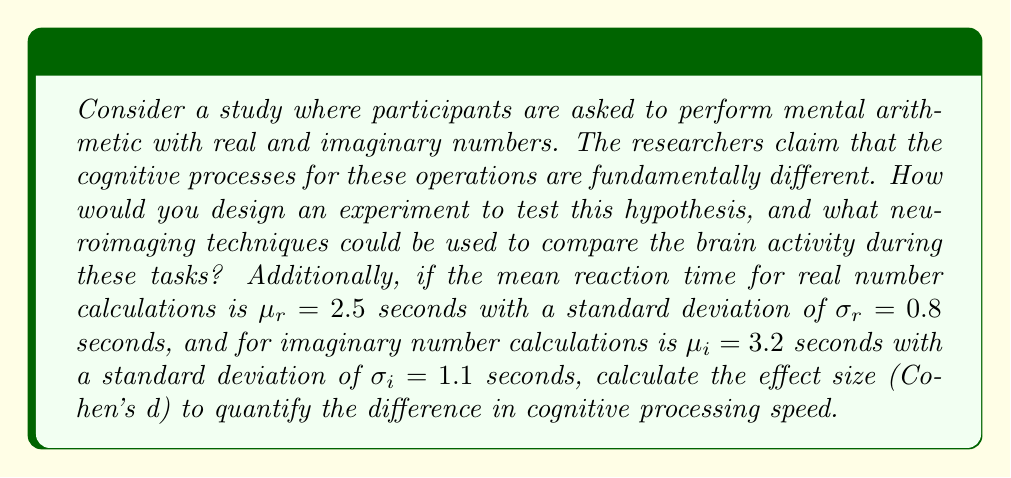Could you help me with this problem? To address this question from a psychological perspective, we need to consider both the experimental design and the statistical analysis:

1. Experimental Design:
   - Use a within-subjects design where each participant performs both real and imaginary number calculations.
   - Counterbalance the order of tasks to control for order effects.
   - Ensure matched difficulty levels for both types of calculations.
   - Use a variety of operations (addition, multiplication, etc.) for both number types.

2. Neuroimaging Techniques:
   - fMRI (functional Magnetic Resonance Imaging) to observe brain activation patterns during tasks.
   - EEG (Electroencephalography) to measure electrical activity and compare event-related potentials.

3. Effect Size Calculation:
   To calculate Cohen's d, we use the formula:

   $$d = \frac{|\mu_1 - \mu_2|}{\sqrt{\frac{\sigma_1^2 + \sigma_2^2}{2}}}$$

   Where:
   $\mu_1$ and $\mu_2$ are the means of the two groups
   $\sigma_1$ and $\sigma_2$ are the standard deviations of the two groups

   Substituting the given values:

   $$d = \frac{|2.5 - 3.2|}{\sqrt{\frac{0.8^2 + 1.1^2}{2}}}$$

   $$d = \frac{0.7}{\sqrt{\frac{0.64 + 1.21}{2}}}$$

   $$d = \frac{0.7}{\sqrt{0.925}}$$

   $$d = \frac{0.7}{0.9618}$$

   $$d \approx 0.7278$$

This effect size can be interpreted as follows:
- 0.2 = small effect
- 0.5 = medium effect
- 0.8 = large effect

Therefore, the calculated effect size indicates a medium to large difference in cognitive processing speed between real and imaginary number calculations.
Answer: Cohen's d ≈ 0.7278, indicating a medium to large effect size in the difference of cognitive processing speed between real and imaginary number calculations. 